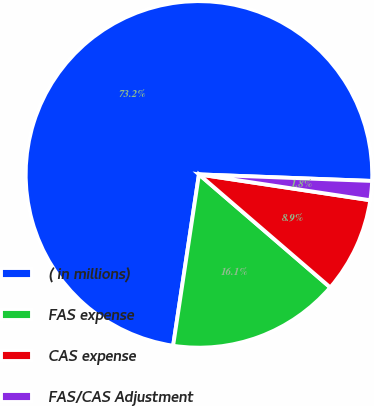Convert chart. <chart><loc_0><loc_0><loc_500><loc_500><pie_chart><fcel>( in millions)<fcel>FAS expense<fcel>CAS expense<fcel>FAS/CAS Adjustment<nl><fcel>73.22%<fcel>16.07%<fcel>8.93%<fcel>1.78%<nl></chart> 